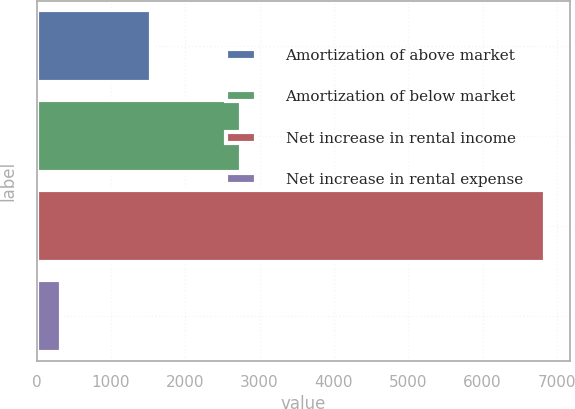Convert chart to OTSL. <chart><loc_0><loc_0><loc_500><loc_500><bar_chart><fcel>Amortization of above market<fcel>Amortization of below market<fcel>Net increase in rental income<fcel>Net increase in rental expense<nl><fcel>1535.2<fcel>2747.4<fcel>6837<fcel>323<nl></chart> 